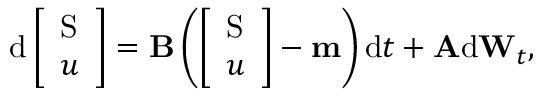<formula> <loc_0><loc_0><loc_500><loc_500>d \left [ \begin{array} { l } { S } \\ { u } \end{array} \right ] = B \left ( \left [ \begin{array} { l } { S } \\ { u } \end{array} \right ] - m \right ) d t + A d W _ { t } ,</formula> 